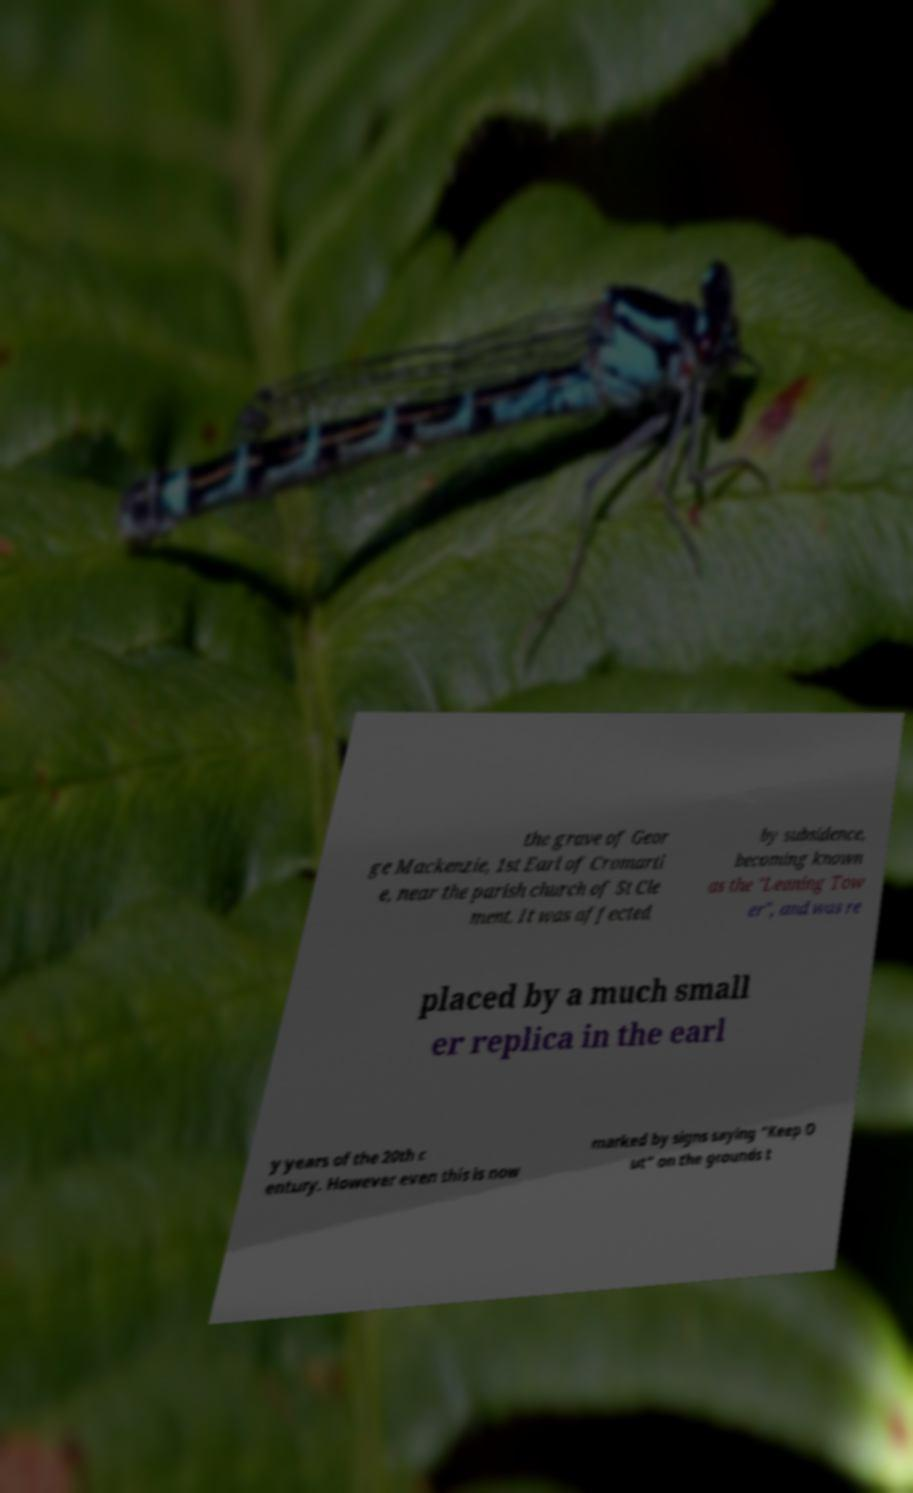Can you accurately transcribe the text from the provided image for me? the grave of Geor ge Mackenzie, 1st Earl of Cromarti e, near the parish church of St Cle ment. It was affected by subsidence, becoming known as the "Leaning Tow er", and was re placed by a much small er replica in the earl y years of the 20th c entury. However even this is now marked by signs saying "Keep O ut" on the grounds t 